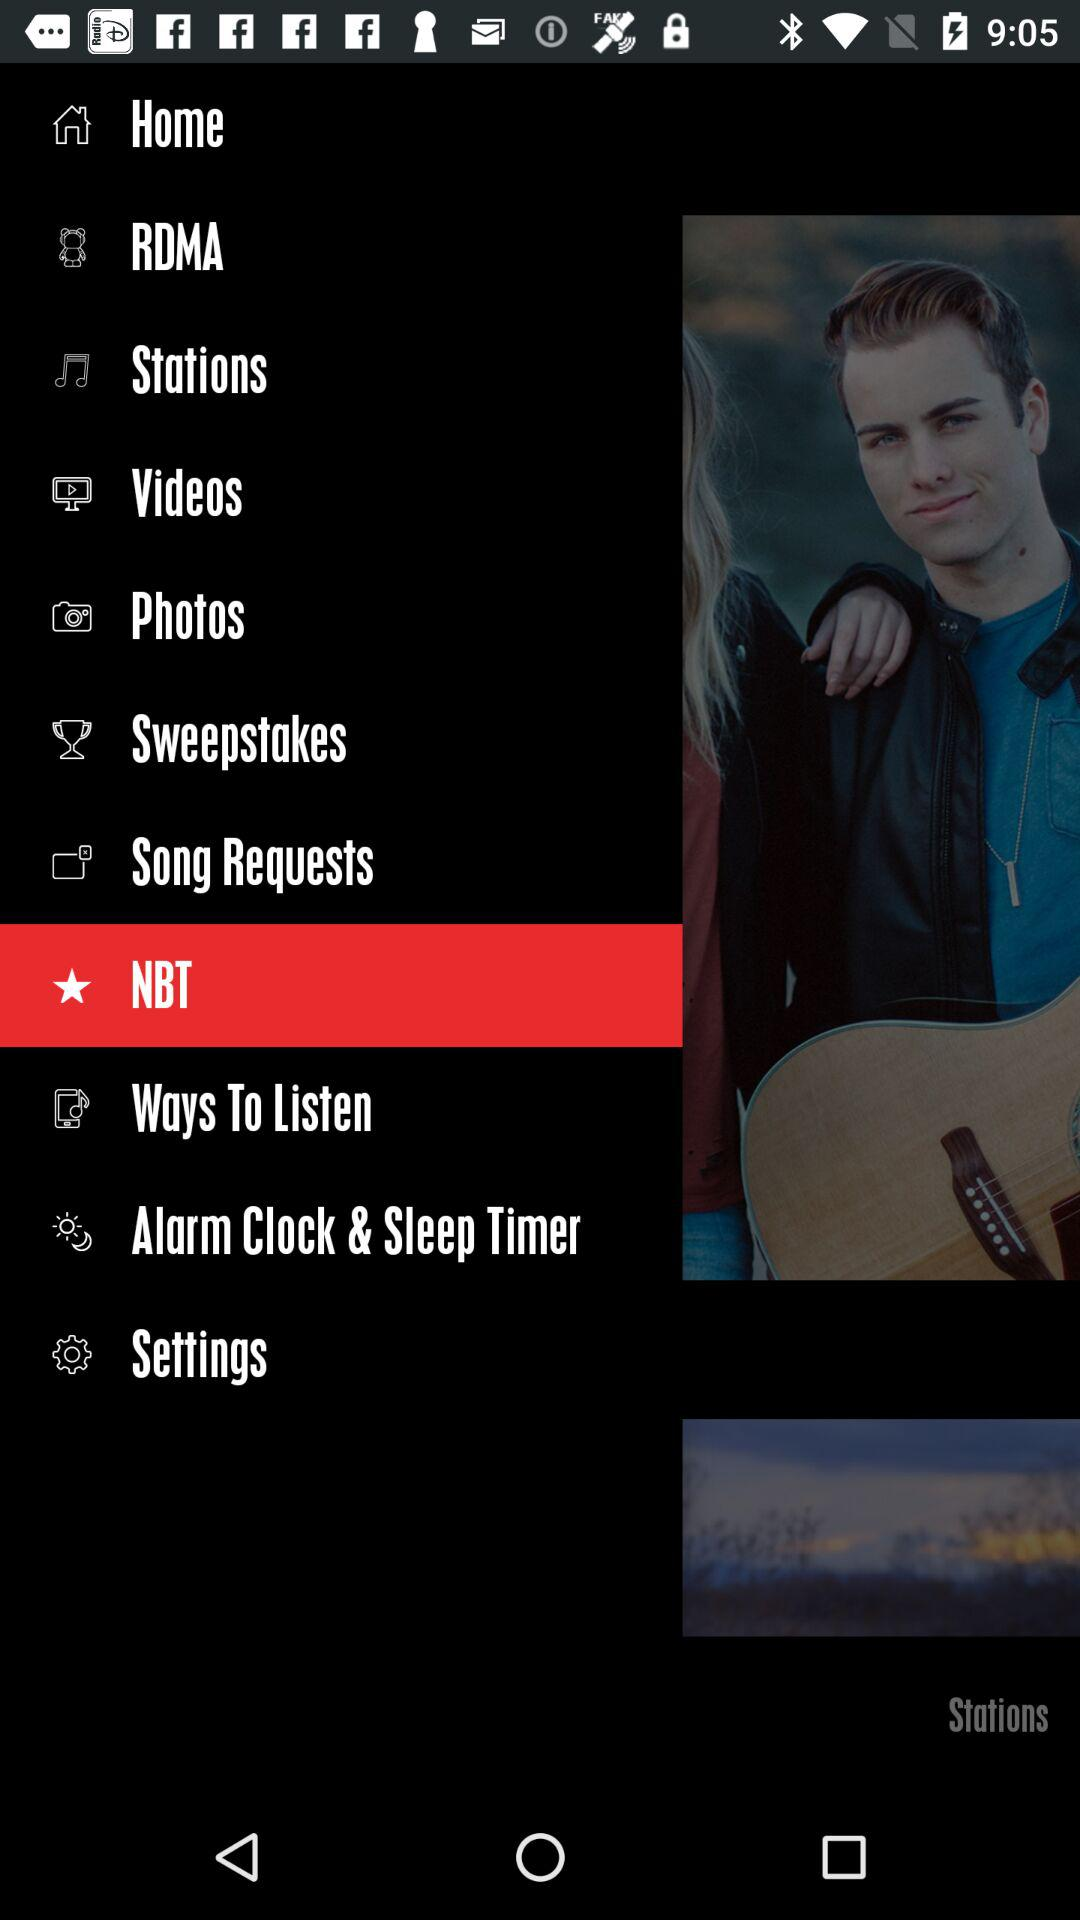Which item is selected? The selected item is "NBT". 